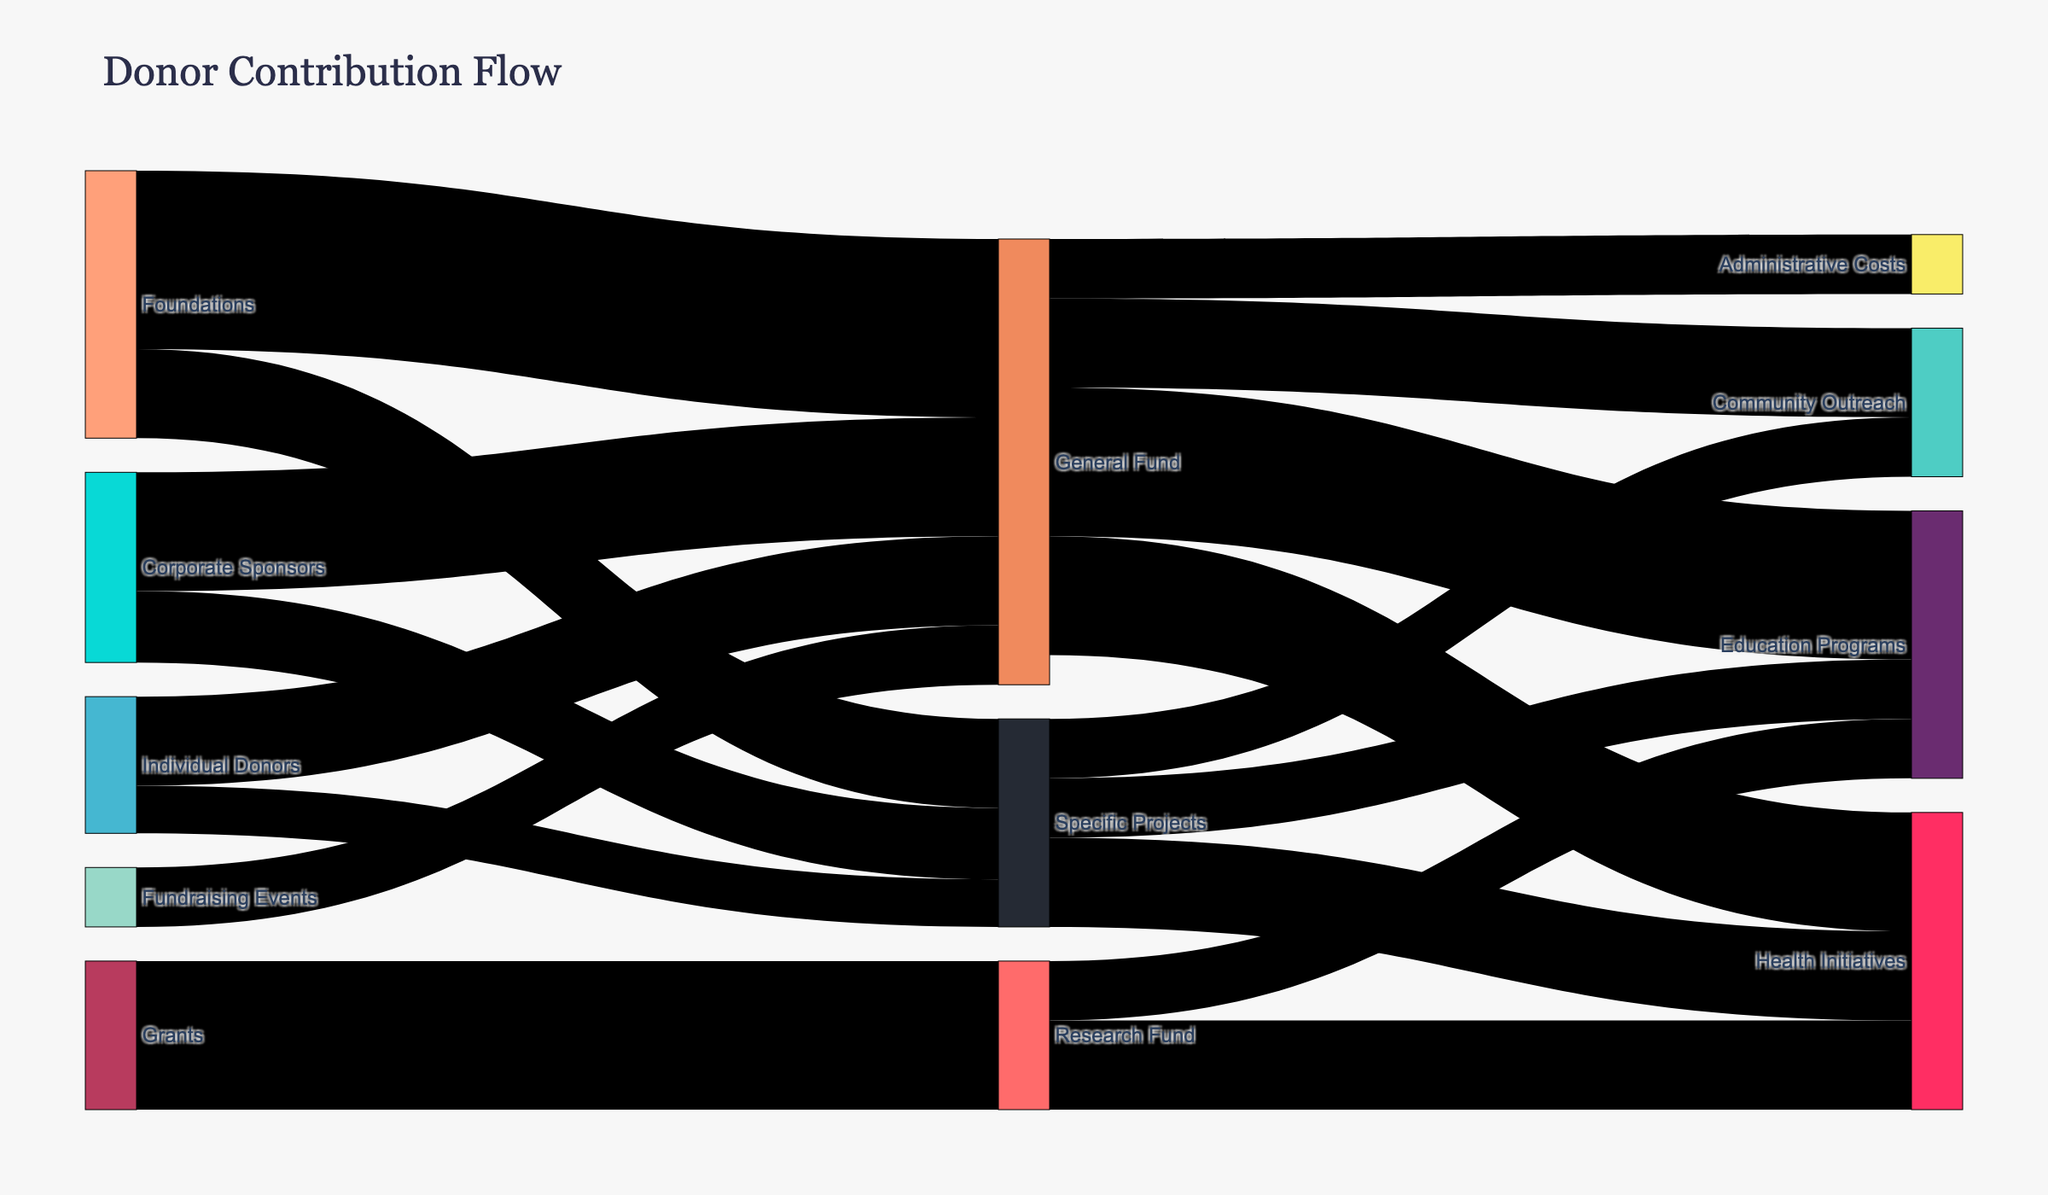what is the title of the Sankey Diagram? The title of the diagram is prominently displayed at the top of the figure.
Answer: "Donor Contribution Flow" which funding source contributes the most to the General Fund? By examining the links leading to the General Fund, we can see that the Foundations contribute $300,000, which is the highest amount from a single source.
Answer: Foundations how much is contributed by Individual Donors to Specific Projects? Locate the link from Individual Donors to Specific Projects, which is labeled with a value indicating the contribution amount.
Answer: $80,000 what is the total amount allocated to Health Initiatives from all sources? Adding the funds flowing into Health Initiatives from General Fund ($200,000), Specific Projects ($150,000), and Research Fund ($150,000) gives a total of $500,000.
Answer: $500,000 how does the contribution to Community Outreach from the General Fund compare to that from Specific Projects? The amounts are $150,000 from the General Fund and $100,000 from Specific Projects. Comparing these, the General Fund contributes more by $50,000.
Answer: General Fund contributes more by $50,000 what are the sources of funds allocated to Education Programs? The sources are the General Fund and the Research Fund, with contributions of $250,000 and $100,000 respectively.
Answer: General Fund and Research Fund what is the overall contribution of Corporate Sponsors to all funds and projects? Adding the contributions to the General Fund ($200,000) and Specific Projects ($120,000), the total is $320,000.
Answer: $320,000 what is the difference between the contributions of Fundraising Events and Individual Donors to the General Fund? Fundraising Events contribute $100,000, while Individual Donors contribute $150,000. The difference is $50,000.
Answer: $50,000 what is the total value of the General Fund? Adding the values from all sources to the General Fund: Individual Donors ($150,000), Corporate Sponsors ($200,000), Foundations ($300,000), and Fundraising Events ($100,000) gives a total of $750,000.
Answer: $750,000 which specific program area receives the least funding and how much does it receive? By observing the flow to different program areas, Administrative Costs receive the least funding of $100,000 from the General Fund.
Answer: Administrative Costs, $100,000 